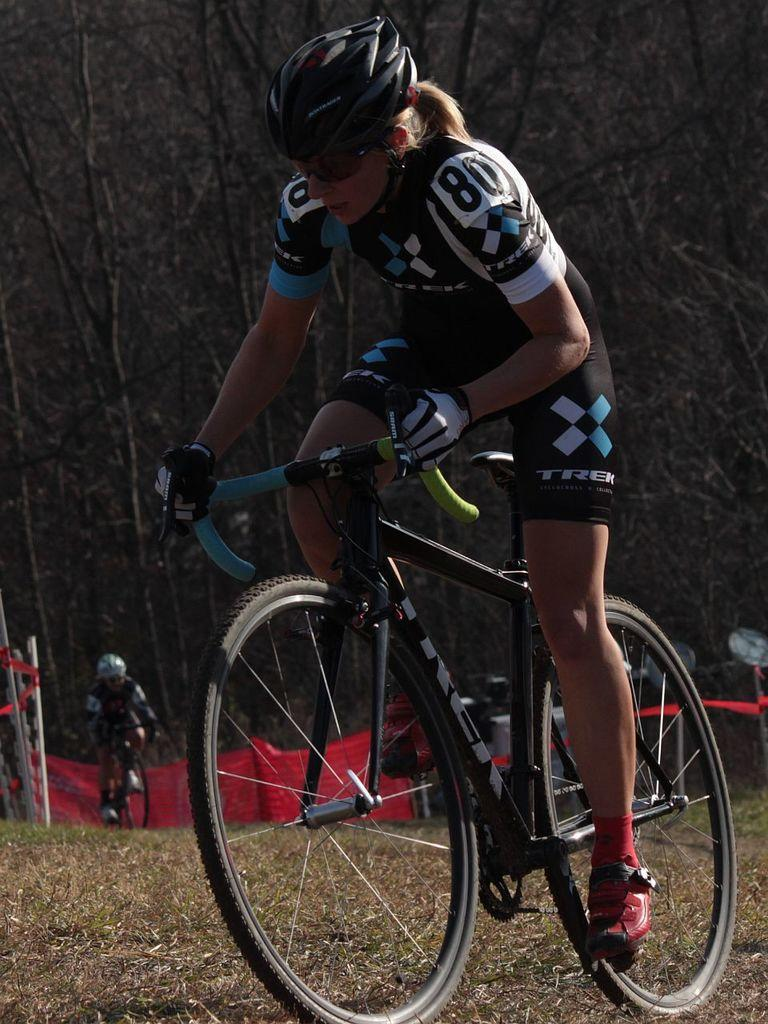What activity are the people in the image engaged in? The people in the image are cycling. Where is the cycling taking place? The cycling is taking place on land. What can be seen in the background of the image? There are banners and trees in the background of the image. How many cushions are being used by the cyclists in the image? There are no cushions present in the image; the cyclists are riding bicycles. 